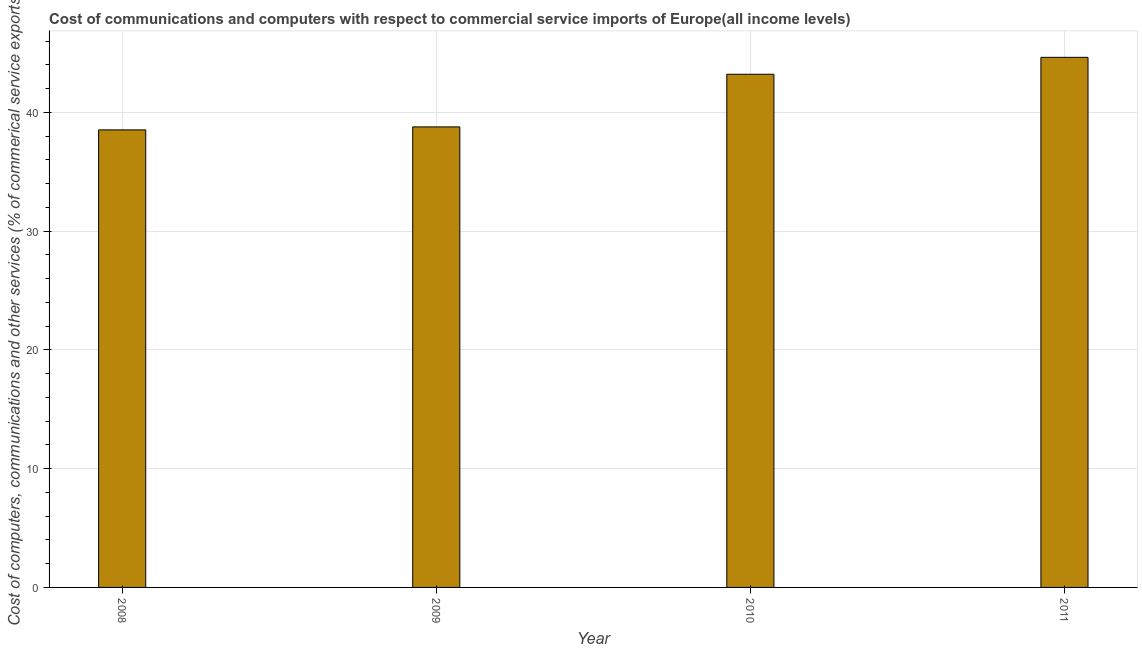Does the graph contain grids?
Keep it short and to the point. Yes. What is the title of the graph?
Provide a short and direct response. Cost of communications and computers with respect to commercial service imports of Europe(all income levels). What is the label or title of the Y-axis?
Give a very brief answer. Cost of computers, communications and other services (% of commerical service exports). What is the cost of communications in 2011?
Provide a succinct answer. 44.63. Across all years, what is the maximum cost of communications?
Provide a short and direct response. 44.63. Across all years, what is the minimum  computer and other services?
Make the answer very short. 38.52. In which year was the cost of communications maximum?
Your answer should be very brief. 2011. In which year was the cost of communications minimum?
Ensure brevity in your answer.  2008. What is the sum of the  computer and other services?
Offer a very short reply. 165.12. What is the difference between the cost of communications in 2008 and 2011?
Provide a short and direct response. -6.11. What is the average  computer and other services per year?
Provide a succinct answer. 41.28. What is the median cost of communications?
Give a very brief answer. 40.99. Do a majority of the years between 2011 and 2010 (inclusive) have  computer and other services greater than 12 %?
Give a very brief answer. No. Is the  computer and other services in 2008 less than that in 2011?
Your answer should be very brief. Yes. What is the difference between the highest and the second highest cost of communications?
Provide a succinct answer. 1.43. Is the sum of the  computer and other services in 2008 and 2009 greater than the maximum  computer and other services across all years?
Your answer should be very brief. Yes. What is the difference between the highest and the lowest  computer and other services?
Provide a short and direct response. 6.11. How many bars are there?
Keep it short and to the point. 4. Are all the bars in the graph horizontal?
Provide a short and direct response. No. What is the difference between two consecutive major ticks on the Y-axis?
Ensure brevity in your answer.  10. What is the Cost of computers, communications and other services (% of commerical service exports) in 2008?
Keep it short and to the point. 38.52. What is the Cost of computers, communications and other services (% of commerical service exports) in 2009?
Give a very brief answer. 38.77. What is the Cost of computers, communications and other services (% of commerical service exports) of 2010?
Your answer should be very brief. 43.2. What is the Cost of computers, communications and other services (% of commerical service exports) in 2011?
Give a very brief answer. 44.63. What is the difference between the Cost of computers, communications and other services (% of commerical service exports) in 2008 and 2009?
Your answer should be compact. -0.25. What is the difference between the Cost of computers, communications and other services (% of commerical service exports) in 2008 and 2010?
Your answer should be compact. -4.68. What is the difference between the Cost of computers, communications and other services (% of commerical service exports) in 2008 and 2011?
Keep it short and to the point. -6.11. What is the difference between the Cost of computers, communications and other services (% of commerical service exports) in 2009 and 2010?
Your answer should be very brief. -4.43. What is the difference between the Cost of computers, communications and other services (% of commerical service exports) in 2009 and 2011?
Keep it short and to the point. -5.86. What is the difference between the Cost of computers, communications and other services (% of commerical service exports) in 2010 and 2011?
Keep it short and to the point. -1.43. What is the ratio of the Cost of computers, communications and other services (% of commerical service exports) in 2008 to that in 2009?
Make the answer very short. 0.99. What is the ratio of the Cost of computers, communications and other services (% of commerical service exports) in 2008 to that in 2010?
Give a very brief answer. 0.89. What is the ratio of the Cost of computers, communications and other services (% of commerical service exports) in 2008 to that in 2011?
Your answer should be very brief. 0.86. What is the ratio of the Cost of computers, communications and other services (% of commerical service exports) in 2009 to that in 2010?
Your answer should be very brief. 0.9. What is the ratio of the Cost of computers, communications and other services (% of commerical service exports) in 2009 to that in 2011?
Provide a short and direct response. 0.87. What is the ratio of the Cost of computers, communications and other services (% of commerical service exports) in 2010 to that in 2011?
Provide a succinct answer. 0.97. 